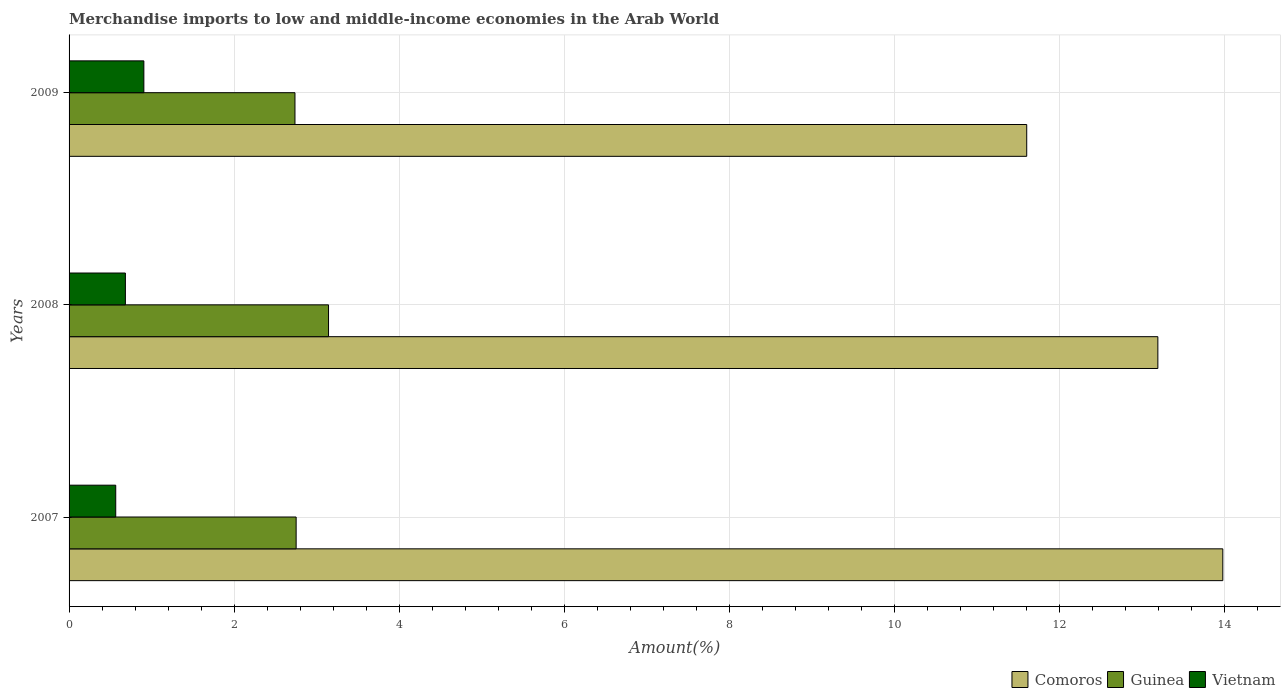Are the number of bars per tick equal to the number of legend labels?
Your answer should be compact. Yes. How many bars are there on the 3rd tick from the top?
Ensure brevity in your answer.  3. In how many cases, is the number of bars for a given year not equal to the number of legend labels?
Provide a succinct answer. 0. What is the percentage of amount earned from merchandise imports in Guinea in 2007?
Offer a very short reply. 2.75. Across all years, what is the maximum percentage of amount earned from merchandise imports in Guinea?
Provide a succinct answer. 3.14. Across all years, what is the minimum percentage of amount earned from merchandise imports in Guinea?
Provide a short and direct response. 2.74. In which year was the percentage of amount earned from merchandise imports in Comoros minimum?
Offer a terse response. 2009. What is the total percentage of amount earned from merchandise imports in Guinea in the graph?
Your answer should be very brief. 8.63. What is the difference between the percentage of amount earned from merchandise imports in Vietnam in 2007 and that in 2008?
Provide a succinct answer. -0.12. What is the difference between the percentage of amount earned from merchandise imports in Guinea in 2009 and the percentage of amount earned from merchandise imports in Vietnam in 2008?
Your answer should be compact. 2.05. What is the average percentage of amount earned from merchandise imports in Vietnam per year?
Keep it short and to the point. 0.72. In the year 2009, what is the difference between the percentage of amount earned from merchandise imports in Comoros and percentage of amount earned from merchandise imports in Vietnam?
Your answer should be compact. 10.7. In how many years, is the percentage of amount earned from merchandise imports in Vietnam greater than 4.8 %?
Your answer should be compact. 0. What is the ratio of the percentage of amount earned from merchandise imports in Comoros in 2007 to that in 2008?
Provide a short and direct response. 1.06. Is the percentage of amount earned from merchandise imports in Guinea in 2007 less than that in 2009?
Your response must be concise. No. Is the difference between the percentage of amount earned from merchandise imports in Comoros in 2007 and 2008 greater than the difference between the percentage of amount earned from merchandise imports in Vietnam in 2007 and 2008?
Make the answer very short. Yes. What is the difference between the highest and the second highest percentage of amount earned from merchandise imports in Vietnam?
Make the answer very short. 0.22. What is the difference between the highest and the lowest percentage of amount earned from merchandise imports in Vietnam?
Offer a very short reply. 0.34. Is the sum of the percentage of amount earned from merchandise imports in Comoros in 2008 and 2009 greater than the maximum percentage of amount earned from merchandise imports in Vietnam across all years?
Offer a very short reply. Yes. What does the 3rd bar from the top in 2007 represents?
Offer a terse response. Comoros. What does the 2nd bar from the bottom in 2008 represents?
Offer a terse response. Guinea. Are all the bars in the graph horizontal?
Provide a short and direct response. Yes. What is the difference between two consecutive major ticks on the X-axis?
Your answer should be compact. 2. Are the values on the major ticks of X-axis written in scientific E-notation?
Keep it short and to the point. No. Does the graph contain any zero values?
Keep it short and to the point. No. Where does the legend appear in the graph?
Give a very brief answer. Bottom right. What is the title of the graph?
Provide a succinct answer. Merchandise imports to low and middle-income economies in the Arab World. Does "Isle of Man" appear as one of the legend labels in the graph?
Your response must be concise. No. What is the label or title of the X-axis?
Provide a succinct answer. Amount(%). What is the Amount(%) in Comoros in 2007?
Offer a terse response. 13.98. What is the Amount(%) of Guinea in 2007?
Make the answer very short. 2.75. What is the Amount(%) in Vietnam in 2007?
Your response must be concise. 0.57. What is the Amount(%) in Comoros in 2008?
Your answer should be very brief. 13.19. What is the Amount(%) of Guinea in 2008?
Your answer should be very brief. 3.14. What is the Amount(%) of Vietnam in 2008?
Provide a short and direct response. 0.68. What is the Amount(%) of Comoros in 2009?
Provide a succinct answer. 11.6. What is the Amount(%) of Guinea in 2009?
Provide a succinct answer. 2.74. What is the Amount(%) in Vietnam in 2009?
Your answer should be very brief. 0.91. Across all years, what is the maximum Amount(%) of Comoros?
Give a very brief answer. 13.98. Across all years, what is the maximum Amount(%) of Guinea?
Ensure brevity in your answer.  3.14. Across all years, what is the maximum Amount(%) in Vietnam?
Give a very brief answer. 0.91. Across all years, what is the minimum Amount(%) in Comoros?
Your response must be concise. 11.6. Across all years, what is the minimum Amount(%) of Guinea?
Give a very brief answer. 2.74. Across all years, what is the minimum Amount(%) of Vietnam?
Provide a succinct answer. 0.57. What is the total Amount(%) of Comoros in the graph?
Provide a short and direct response. 38.77. What is the total Amount(%) in Guinea in the graph?
Provide a short and direct response. 8.63. What is the total Amount(%) in Vietnam in the graph?
Make the answer very short. 2.15. What is the difference between the Amount(%) in Comoros in 2007 and that in 2008?
Offer a terse response. 0.79. What is the difference between the Amount(%) in Guinea in 2007 and that in 2008?
Offer a very short reply. -0.39. What is the difference between the Amount(%) of Vietnam in 2007 and that in 2008?
Provide a short and direct response. -0.12. What is the difference between the Amount(%) in Comoros in 2007 and that in 2009?
Keep it short and to the point. 2.38. What is the difference between the Amount(%) in Guinea in 2007 and that in 2009?
Your answer should be compact. 0.01. What is the difference between the Amount(%) of Vietnam in 2007 and that in 2009?
Offer a terse response. -0.34. What is the difference between the Amount(%) of Comoros in 2008 and that in 2009?
Offer a very short reply. 1.59. What is the difference between the Amount(%) of Guinea in 2008 and that in 2009?
Offer a terse response. 0.41. What is the difference between the Amount(%) in Vietnam in 2008 and that in 2009?
Ensure brevity in your answer.  -0.22. What is the difference between the Amount(%) in Comoros in 2007 and the Amount(%) in Guinea in 2008?
Your response must be concise. 10.83. What is the difference between the Amount(%) of Comoros in 2007 and the Amount(%) of Vietnam in 2008?
Offer a terse response. 13.29. What is the difference between the Amount(%) in Guinea in 2007 and the Amount(%) in Vietnam in 2008?
Keep it short and to the point. 2.07. What is the difference between the Amount(%) in Comoros in 2007 and the Amount(%) in Guinea in 2009?
Offer a terse response. 11.24. What is the difference between the Amount(%) in Comoros in 2007 and the Amount(%) in Vietnam in 2009?
Your response must be concise. 13.07. What is the difference between the Amount(%) in Guinea in 2007 and the Amount(%) in Vietnam in 2009?
Your answer should be very brief. 1.84. What is the difference between the Amount(%) in Comoros in 2008 and the Amount(%) in Guinea in 2009?
Offer a terse response. 10.45. What is the difference between the Amount(%) of Comoros in 2008 and the Amount(%) of Vietnam in 2009?
Keep it short and to the point. 12.28. What is the difference between the Amount(%) of Guinea in 2008 and the Amount(%) of Vietnam in 2009?
Provide a short and direct response. 2.24. What is the average Amount(%) in Comoros per year?
Make the answer very short. 12.92. What is the average Amount(%) in Guinea per year?
Keep it short and to the point. 2.88. What is the average Amount(%) of Vietnam per year?
Provide a succinct answer. 0.72. In the year 2007, what is the difference between the Amount(%) of Comoros and Amount(%) of Guinea?
Your answer should be compact. 11.23. In the year 2007, what is the difference between the Amount(%) in Comoros and Amount(%) in Vietnam?
Your answer should be very brief. 13.41. In the year 2007, what is the difference between the Amount(%) of Guinea and Amount(%) of Vietnam?
Provide a short and direct response. 2.19. In the year 2008, what is the difference between the Amount(%) of Comoros and Amount(%) of Guinea?
Ensure brevity in your answer.  10.05. In the year 2008, what is the difference between the Amount(%) in Comoros and Amount(%) in Vietnam?
Ensure brevity in your answer.  12.51. In the year 2008, what is the difference between the Amount(%) in Guinea and Amount(%) in Vietnam?
Your answer should be compact. 2.46. In the year 2009, what is the difference between the Amount(%) in Comoros and Amount(%) in Guinea?
Provide a short and direct response. 8.86. In the year 2009, what is the difference between the Amount(%) of Comoros and Amount(%) of Vietnam?
Provide a short and direct response. 10.7. In the year 2009, what is the difference between the Amount(%) of Guinea and Amount(%) of Vietnam?
Your response must be concise. 1.83. What is the ratio of the Amount(%) in Comoros in 2007 to that in 2008?
Make the answer very short. 1.06. What is the ratio of the Amount(%) in Guinea in 2007 to that in 2008?
Provide a succinct answer. 0.88. What is the ratio of the Amount(%) of Vietnam in 2007 to that in 2008?
Offer a very short reply. 0.83. What is the ratio of the Amount(%) in Comoros in 2007 to that in 2009?
Provide a succinct answer. 1.2. What is the ratio of the Amount(%) of Vietnam in 2007 to that in 2009?
Give a very brief answer. 0.62. What is the ratio of the Amount(%) of Comoros in 2008 to that in 2009?
Keep it short and to the point. 1.14. What is the ratio of the Amount(%) in Guinea in 2008 to that in 2009?
Make the answer very short. 1.15. What is the ratio of the Amount(%) in Vietnam in 2008 to that in 2009?
Your response must be concise. 0.75. What is the difference between the highest and the second highest Amount(%) of Comoros?
Provide a short and direct response. 0.79. What is the difference between the highest and the second highest Amount(%) in Guinea?
Your answer should be very brief. 0.39. What is the difference between the highest and the second highest Amount(%) of Vietnam?
Your answer should be very brief. 0.22. What is the difference between the highest and the lowest Amount(%) of Comoros?
Keep it short and to the point. 2.38. What is the difference between the highest and the lowest Amount(%) in Guinea?
Your answer should be compact. 0.41. What is the difference between the highest and the lowest Amount(%) of Vietnam?
Make the answer very short. 0.34. 